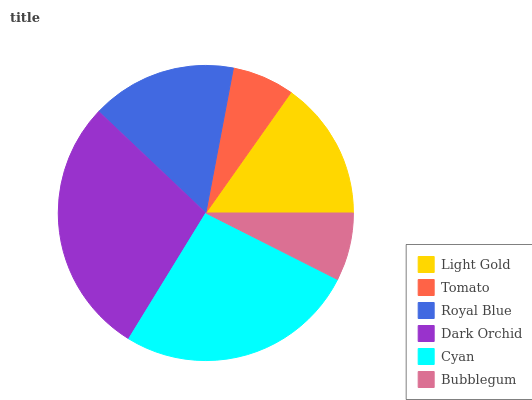Is Tomato the minimum?
Answer yes or no. Yes. Is Dark Orchid the maximum?
Answer yes or no. Yes. Is Royal Blue the minimum?
Answer yes or no. No. Is Royal Blue the maximum?
Answer yes or no. No. Is Royal Blue greater than Tomato?
Answer yes or no. Yes. Is Tomato less than Royal Blue?
Answer yes or no. Yes. Is Tomato greater than Royal Blue?
Answer yes or no. No. Is Royal Blue less than Tomato?
Answer yes or no. No. Is Royal Blue the high median?
Answer yes or no. Yes. Is Light Gold the low median?
Answer yes or no. Yes. Is Light Gold the high median?
Answer yes or no. No. Is Royal Blue the low median?
Answer yes or no. No. 